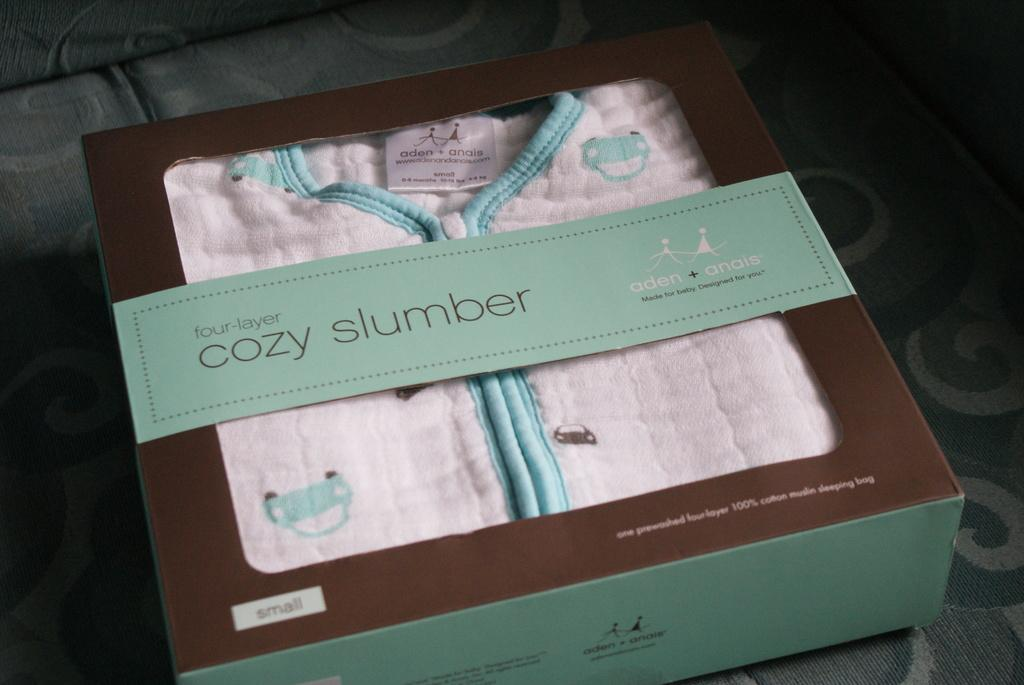What is inside the cardboard box in the image? There is a dress in a cardboard box in the image. Where is the cardboard box located? The cardboard box is placed on a sofa. What type of food is being prepared on the vein in the image? There is no food or vein present in the image; it only features a dress in a cardboard box placed on a sofa. 